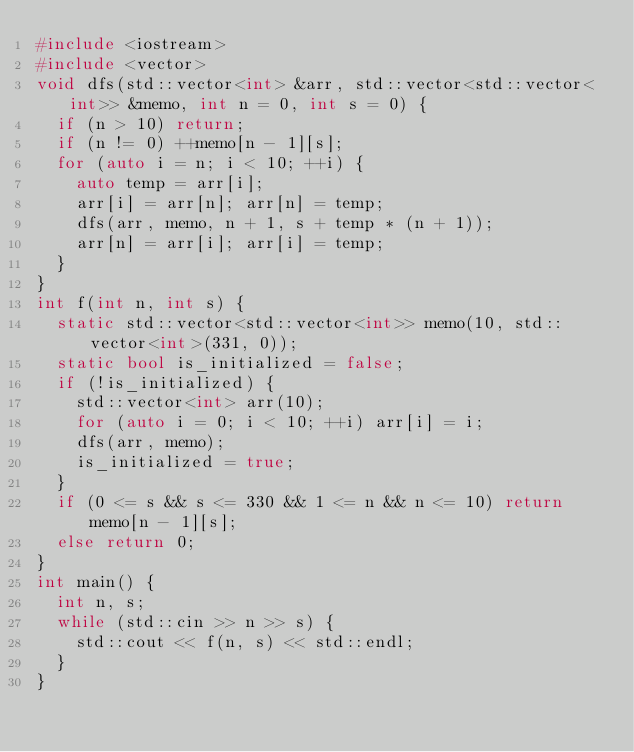Convert code to text. <code><loc_0><loc_0><loc_500><loc_500><_C++_>#include <iostream>
#include <vector>
void dfs(std::vector<int> &arr, std::vector<std::vector<int>> &memo, int n = 0, int s = 0) {
	if (n > 10) return;
	if (n != 0) ++memo[n - 1][s];
	for (auto i = n; i < 10; ++i) {
		auto temp = arr[i];
		arr[i] = arr[n]; arr[n] = temp;
		dfs(arr, memo, n + 1, s + temp * (n + 1));
		arr[n] = arr[i]; arr[i] = temp;
	}
}
int f(int n, int s) {
	static std::vector<std::vector<int>> memo(10, std::vector<int>(331, 0));
	static bool is_initialized = false;
	if (!is_initialized) {
		std::vector<int> arr(10);
		for (auto i = 0; i < 10; ++i) arr[i] = i;
		dfs(arr, memo);
		is_initialized = true;
	}
	if (0 <= s && s <= 330 && 1 <= n && n <= 10) return memo[n - 1][s];
	else return 0;
}
int main() {
	int n, s;
	while (std::cin >> n >> s) {
		std::cout << f(n, s) << std::endl;
	}
}
</code> 